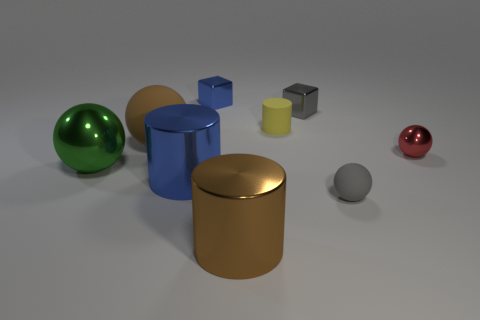Subtract all balls. How many objects are left? 5 Subtract all tiny gray metal cubes. Subtract all tiny gray cubes. How many objects are left? 7 Add 4 blue shiny objects. How many blue shiny objects are left? 6 Add 9 green blocks. How many green blocks exist? 9 Subtract 0 cyan cylinders. How many objects are left? 9 